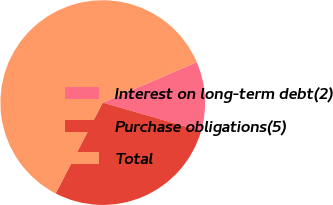<chart> <loc_0><loc_0><loc_500><loc_500><pie_chart><fcel>Interest on long-term debt(2)<fcel>Purchase obligations(5)<fcel>Total<nl><fcel>10.95%<fcel>28.13%<fcel>60.91%<nl></chart> 